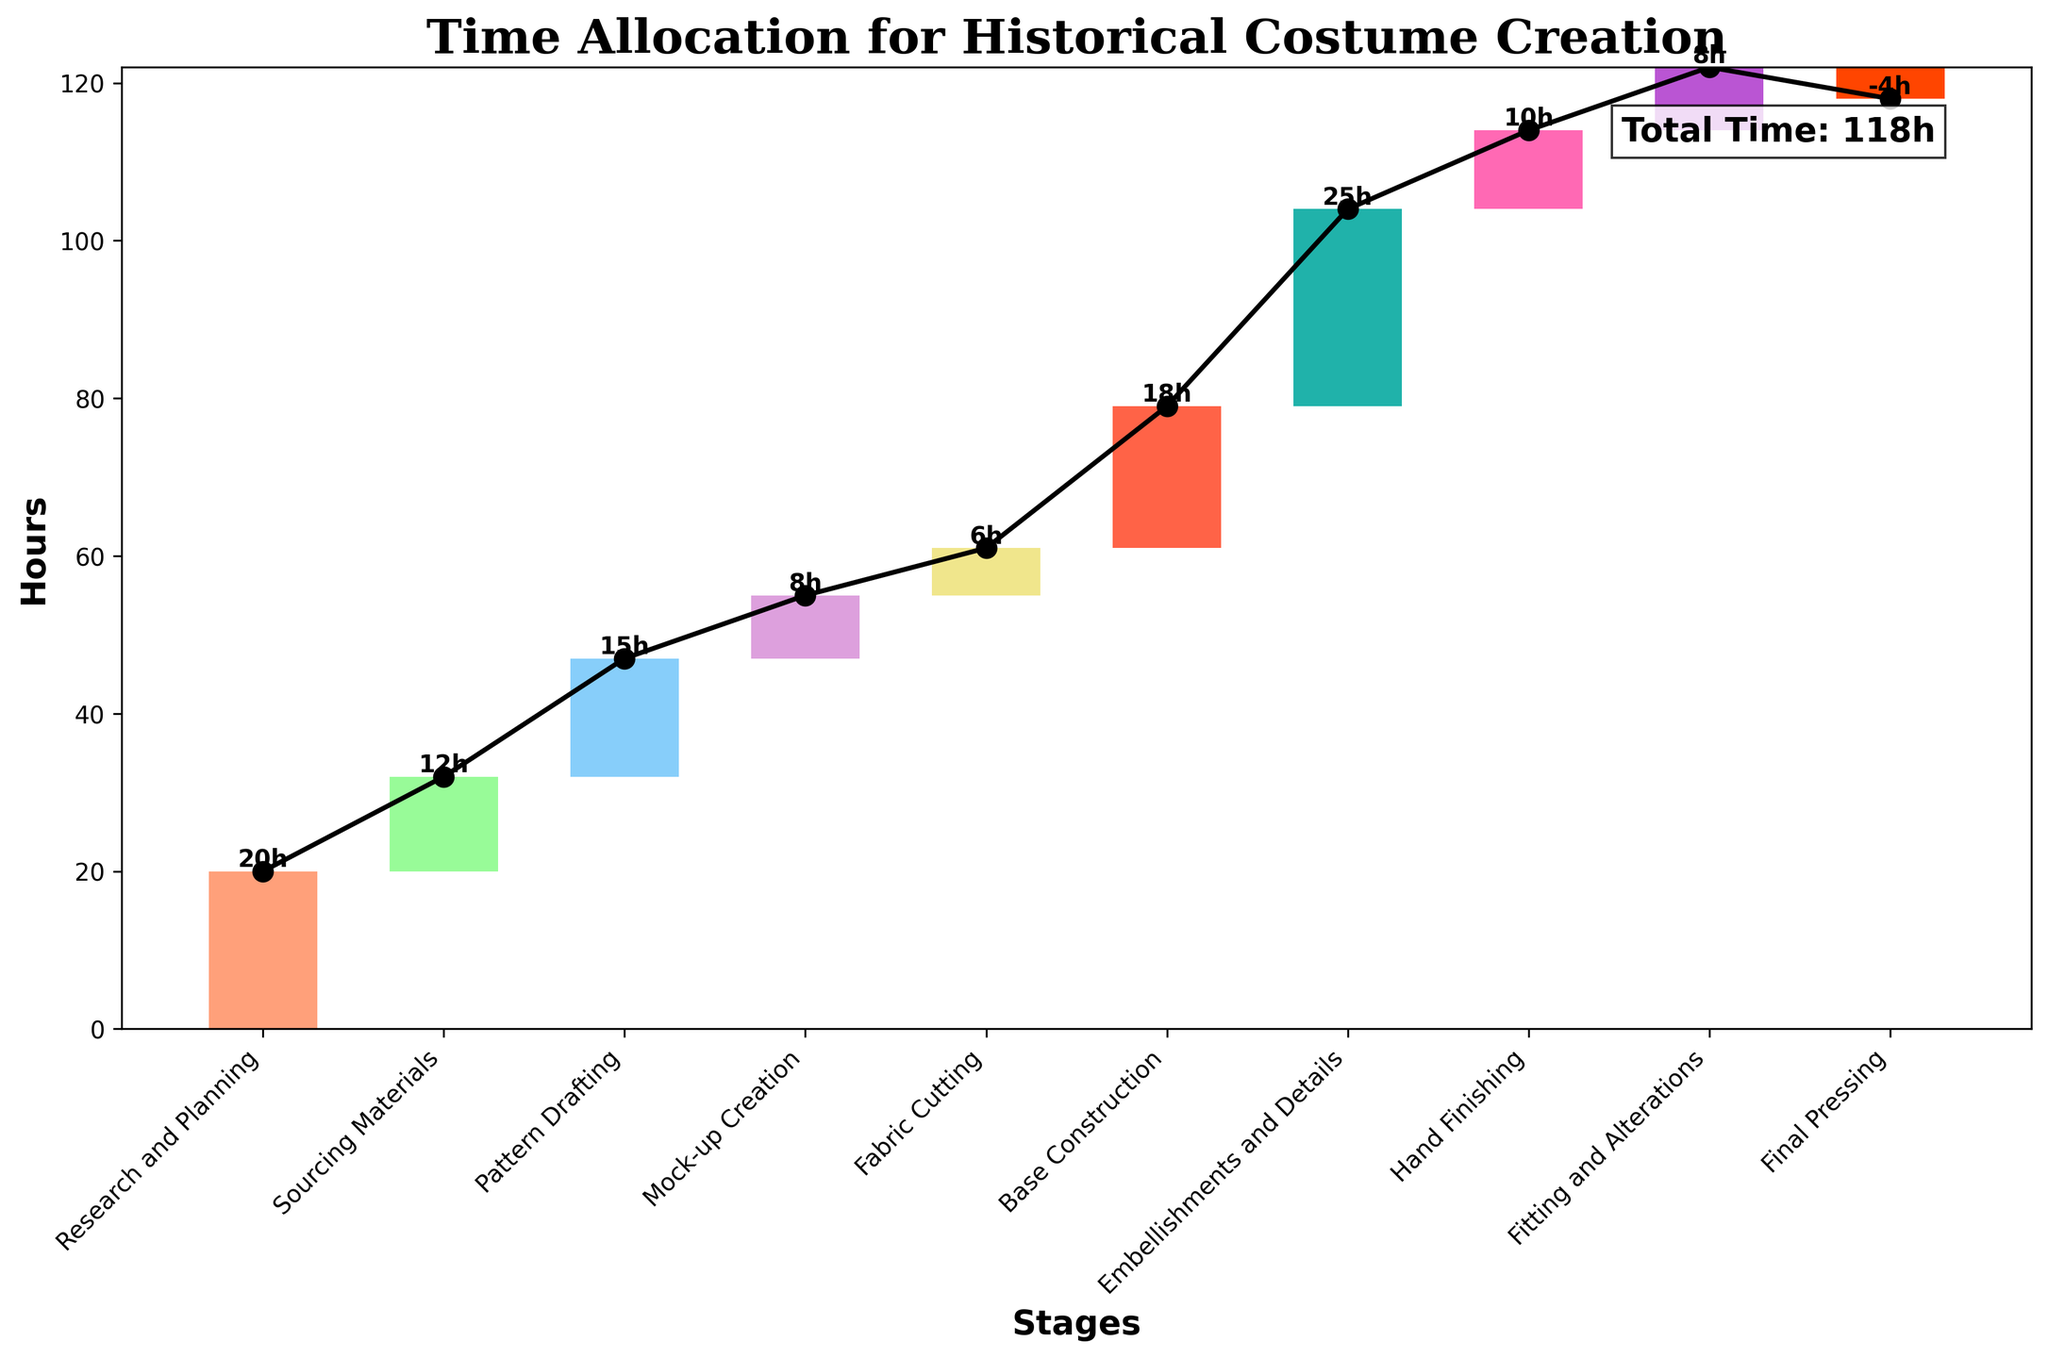What is the title of the figure? The title is usually located at the top of the chart. Here, it indicates the overall topic of the figure.
Answer: Time Allocation for Historical Costume Creation How many stages are listed in the chart before the 'Total Time'? Count the number of bars (or stages) listed in the chart before the 'Total Time' is shown.
Answer: 10 What stage took the most hours to complete? Look at the height of the bars in the chart to identify which one is the tallest.
Answer: Embellishments and Details What is the cumulative time spent after the 'Base Construction' stage? Add up the hours for all stages up to and including 'Base Construction'. Here's the step: 20 (Research and Planning) + 12 (Sourcing Materials) + 15 (Pattern Drafting) + 8 (Mock-up Creation) + 6 (Fabric Cutting) + 18 (Base Construction) = 79 hours.
Answer: 79 hours Which stage required the least amount of time? Assess the height of all bars and determine the shortest one.
Answer: Final Pressing How much less time was spent on 'Mock-up Creation' compared to 'Pattern Drafting'? Subtract the hours for 'Mock-up Creation' from 'Pattern Drafting'. The values are 15 (Pattern Drafting) - 8 (Mock-up Creation) = 7 hours.
Answer: 7 hours What is the total time spent on stages involving actual sewing and assembly? Sum up the hours for stages directly related to sewing and assembly: 'Base Construction', 'Embellishments and Details', 'Hand Finishing', and 'Fitting and Alterations'. The hours are 18 + 25 + 10 + 8 = 61 hours.
Answer: 61 hours What percentage of the total time was spent on 'Research and Planning'? Divide the hours spent on 'Research and Planning' by the total time (excluding the 'Total Time' step) and multiply by 100. The calculation is (20 / 118) * 100 ≈ 16.95%.
Answer: Approximately 16.95% How does the total time spent on 'Sourcing Materials' compare to 'Mock-up Creation' and 'Fabric Cutting' combined? Add the hours for 'Mock-up Creation' and 'Fabric Cutting' and compare it to 'Sourcing Materials'. The calculation is 8 (Mock-up Creation) + 6 (Fabric Cutting) = 14 hours, which is greater than the 12 hours for 'Sourcing Materials'.
Answer: Less time spent What is the cumulative time spent after 'Hand Finishing' but before 'Fitting and Alterations'? Sum the hours up to 'Hand Finishing' and exclude 'Fitting and Alterations'. The calculation is 20 (Research and Planning) + 12 (Sourcing Materials) + 15 (Pattern Drafting) + 8 (Mock-up Creation) + 6 (Fabric Cutting) + 18 (Base Construction) + 25 (Embellishments and Details) + 10 (Hand Finishing) = 114 hours.
Answer: 114 hours 